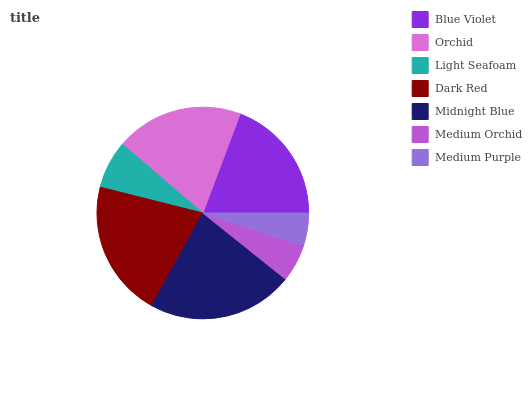Is Medium Purple the minimum?
Answer yes or no. Yes. Is Midnight Blue the maximum?
Answer yes or no. Yes. Is Orchid the minimum?
Answer yes or no. No. Is Orchid the maximum?
Answer yes or no. No. Is Orchid greater than Blue Violet?
Answer yes or no. Yes. Is Blue Violet less than Orchid?
Answer yes or no. Yes. Is Blue Violet greater than Orchid?
Answer yes or no. No. Is Orchid less than Blue Violet?
Answer yes or no. No. Is Blue Violet the high median?
Answer yes or no. Yes. Is Blue Violet the low median?
Answer yes or no. Yes. Is Dark Red the high median?
Answer yes or no. No. Is Midnight Blue the low median?
Answer yes or no. No. 